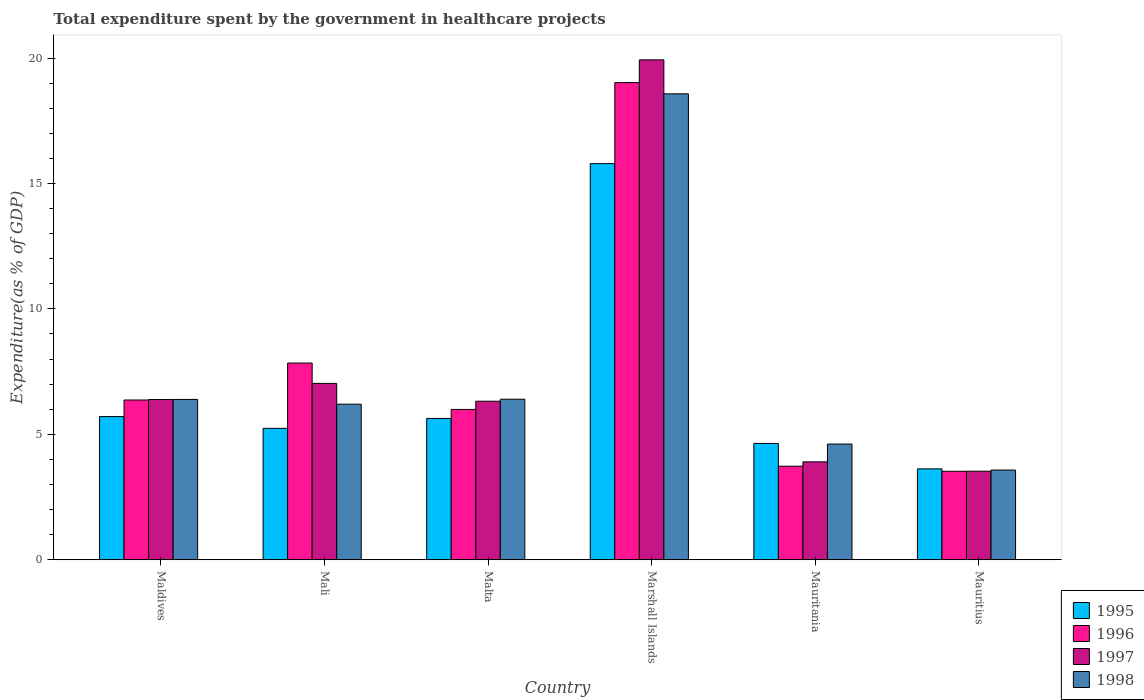Are the number of bars per tick equal to the number of legend labels?
Make the answer very short. Yes. Are the number of bars on each tick of the X-axis equal?
Offer a terse response. Yes. How many bars are there on the 6th tick from the left?
Provide a succinct answer. 4. What is the label of the 4th group of bars from the left?
Ensure brevity in your answer.  Marshall Islands. What is the total expenditure spent by the government in healthcare projects in 1997 in Mauritania?
Ensure brevity in your answer.  3.9. Across all countries, what is the maximum total expenditure spent by the government in healthcare projects in 1995?
Keep it short and to the point. 15.79. Across all countries, what is the minimum total expenditure spent by the government in healthcare projects in 1995?
Provide a succinct answer. 3.62. In which country was the total expenditure spent by the government in healthcare projects in 1995 maximum?
Provide a succinct answer. Marshall Islands. In which country was the total expenditure spent by the government in healthcare projects in 1998 minimum?
Your answer should be compact. Mauritius. What is the total total expenditure spent by the government in healthcare projects in 1996 in the graph?
Provide a succinct answer. 46.48. What is the difference between the total expenditure spent by the government in healthcare projects in 1995 in Malta and that in Marshall Islands?
Your answer should be compact. -10.16. What is the difference between the total expenditure spent by the government in healthcare projects in 1997 in Mali and the total expenditure spent by the government in healthcare projects in 1996 in Mauritius?
Make the answer very short. 3.5. What is the average total expenditure spent by the government in healthcare projects in 1997 per country?
Provide a short and direct response. 7.85. What is the difference between the total expenditure spent by the government in healthcare projects of/in 1995 and total expenditure spent by the government in healthcare projects of/in 1997 in Mauritania?
Give a very brief answer. 0.73. In how many countries, is the total expenditure spent by the government in healthcare projects in 1995 greater than 6 %?
Your answer should be compact. 1. What is the ratio of the total expenditure spent by the government in healthcare projects in 1997 in Mali to that in Marshall Islands?
Your response must be concise. 0.35. Is the total expenditure spent by the government in healthcare projects in 1998 in Maldives less than that in Mali?
Provide a succinct answer. No. What is the difference between the highest and the second highest total expenditure spent by the government in healthcare projects in 1996?
Keep it short and to the point. 12.65. What is the difference between the highest and the lowest total expenditure spent by the government in healthcare projects in 1998?
Your answer should be very brief. 15. In how many countries, is the total expenditure spent by the government in healthcare projects in 1996 greater than the average total expenditure spent by the government in healthcare projects in 1996 taken over all countries?
Offer a terse response. 2. Is it the case that in every country, the sum of the total expenditure spent by the government in healthcare projects in 1995 and total expenditure spent by the government in healthcare projects in 1996 is greater than the sum of total expenditure spent by the government in healthcare projects in 1997 and total expenditure spent by the government in healthcare projects in 1998?
Offer a very short reply. No. What does the 3rd bar from the right in Marshall Islands represents?
Offer a terse response. 1996. How many bars are there?
Provide a short and direct response. 24. What is the difference between two consecutive major ticks on the Y-axis?
Ensure brevity in your answer.  5. Are the values on the major ticks of Y-axis written in scientific E-notation?
Provide a short and direct response. No. Where does the legend appear in the graph?
Your response must be concise. Bottom right. How are the legend labels stacked?
Offer a terse response. Vertical. What is the title of the graph?
Your answer should be very brief. Total expenditure spent by the government in healthcare projects. What is the label or title of the X-axis?
Provide a succinct answer. Country. What is the label or title of the Y-axis?
Give a very brief answer. Expenditure(as % of GDP). What is the Expenditure(as % of GDP) of 1995 in Maldives?
Your answer should be very brief. 5.71. What is the Expenditure(as % of GDP) of 1996 in Maldives?
Provide a succinct answer. 6.37. What is the Expenditure(as % of GDP) of 1997 in Maldives?
Offer a very short reply. 6.39. What is the Expenditure(as % of GDP) in 1998 in Maldives?
Your response must be concise. 6.39. What is the Expenditure(as % of GDP) of 1995 in Mali?
Give a very brief answer. 5.24. What is the Expenditure(as % of GDP) of 1996 in Mali?
Your response must be concise. 7.84. What is the Expenditure(as % of GDP) of 1997 in Mali?
Your response must be concise. 7.03. What is the Expenditure(as % of GDP) in 1998 in Mali?
Make the answer very short. 6.2. What is the Expenditure(as % of GDP) in 1995 in Malta?
Make the answer very short. 5.63. What is the Expenditure(as % of GDP) of 1996 in Malta?
Keep it short and to the point. 5.99. What is the Expenditure(as % of GDP) in 1997 in Malta?
Provide a succinct answer. 6.32. What is the Expenditure(as % of GDP) in 1998 in Malta?
Ensure brevity in your answer.  6.4. What is the Expenditure(as % of GDP) of 1995 in Marshall Islands?
Your answer should be very brief. 15.79. What is the Expenditure(as % of GDP) in 1996 in Marshall Islands?
Your answer should be compact. 19.02. What is the Expenditure(as % of GDP) of 1997 in Marshall Islands?
Your response must be concise. 19.93. What is the Expenditure(as % of GDP) of 1998 in Marshall Islands?
Your answer should be very brief. 18.57. What is the Expenditure(as % of GDP) in 1995 in Mauritania?
Your answer should be very brief. 4.64. What is the Expenditure(as % of GDP) in 1996 in Mauritania?
Your answer should be very brief. 3.73. What is the Expenditure(as % of GDP) in 1997 in Mauritania?
Offer a terse response. 3.9. What is the Expenditure(as % of GDP) in 1998 in Mauritania?
Give a very brief answer. 4.61. What is the Expenditure(as % of GDP) of 1995 in Mauritius?
Offer a terse response. 3.62. What is the Expenditure(as % of GDP) of 1996 in Mauritius?
Provide a short and direct response. 3.53. What is the Expenditure(as % of GDP) of 1997 in Mauritius?
Your response must be concise. 3.53. What is the Expenditure(as % of GDP) in 1998 in Mauritius?
Your answer should be very brief. 3.58. Across all countries, what is the maximum Expenditure(as % of GDP) in 1995?
Give a very brief answer. 15.79. Across all countries, what is the maximum Expenditure(as % of GDP) of 1996?
Offer a very short reply. 19.02. Across all countries, what is the maximum Expenditure(as % of GDP) of 1997?
Provide a short and direct response. 19.93. Across all countries, what is the maximum Expenditure(as % of GDP) in 1998?
Your answer should be compact. 18.57. Across all countries, what is the minimum Expenditure(as % of GDP) in 1995?
Provide a succinct answer. 3.62. Across all countries, what is the minimum Expenditure(as % of GDP) of 1996?
Make the answer very short. 3.53. Across all countries, what is the minimum Expenditure(as % of GDP) in 1997?
Give a very brief answer. 3.53. Across all countries, what is the minimum Expenditure(as % of GDP) of 1998?
Offer a very short reply. 3.58. What is the total Expenditure(as % of GDP) of 1995 in the graph?
Ensure brevity in your answer.  40.63. What is the total Expenditure(as % of GDP) of 1996 in the graph?
Your response must be concise. 46.48. What is the total Expenditure(as % of GDP) of 1997 in the graph?
Provide a succinct answer. 47.09. What is the total Expenditure(as % of GDP) of 1998 in the graph?
Give a very brief answer. 45.75. What is the difference between the Expenditure(as % of GDP) in 1995 in Maldives and that in Mali?
Give a very brief answer. 0.47. What is the difference between the Expenditure(as % of GDP) in 1996 in Maldives and that in Mali?
Your answer should be compact. -1.47. What is the difference between the Expenditure(as % of GDP) in 1997 in Maldives and that in Mali?
Your answer should be very brief. -0.64. What is the difference between the Expenditure(as % of GDP) of 1998 in Maldives and that in Mali?
Keep it short and to the point. 0.19. What is the difference between the Expenditure(as % of GDP) of 1995 in Maldives and that in Malta?
Offer a very short reply. 0.07. What is the difference between the Expenditure(as % of GDP) of 1996 in Maldives and that in Malta?
Offer a very short reply. 0.38. What is the difference between the Expenditure(as % of GDP) in 1997 in Maldives and that in Malta?
Your answer should be very brief. 0.07. What is the difference between the Expenditure(as % of GDP) of 1998 in Maldives and that in Malta?
Ensure brevity in your answer.  -0.01. What is the difference between the Expenditure(as % of GDP) in 1995 in Maldives and that in Marshall Islands?
Offer a terse response. -10.08. What is the difference between the Expenditure(as % of GDP) of 1996 in Maldives and that in Marshall Islands?
Your answer should be very brief. -12.65. What is the difference between the Expenditure(as % of GDP) of 1997 in Maldives and that in Marshall Islands?
Keep it short and to the point. -13.54. What is the difference between the Expenditure(as % of GDP) of 1998 in Maldives and that in Marshall Islands?
Your response must be concise. -12.18. What is the difference between the Expenditure(as % of GDP) of 1995 in Maldives and that in Mauritania?
Make the answer very short. 1.07. What is the difference between the Expenditure(as % of GDP) of 1996 in Maldives and that in Mauritania?
Ensure brevity in your answer.  2.64. What is the difference between the Expenditure(as % of GDP) in 1997 in Maldives and that in Mauritania?
Give a very brief answer. 2.48. What is the difference between the Expenditure(as % of GDP) of 1998 in Maldives and that in Mauritania?
Offer a very short reply. 1.78. What is the difference between the Expenditure(as % of GDP) in 1995 in Maldives and that in Mauritius?
Make the answer very short. 2.08. What is the difference between the Expenditure(as % of GDP) in 1996 in Maldives and that in Mauritius?
Your response must be concise. 2.84. What is the difference between the Expenditure(as % of GDP) of 1997 in Maldives and that in Mauritius?
Offer a terse response. 2.86. What is the difference between the Expenditure(as % of GDP) of 1998 in Maldives and that in Mauritius?
Provide a succinct answer. 2.82. What is the difference between the Expenditure(as % of GDP) in 1995 in Mali and that in Malta?
Offer a terse response. -0.4. What is the difference between the Expenditure(as % of GDP) in 1996 in Mali and that in Malta?
Provide a succinct answer. 1.85. What is the difference between the Expenditure(as % of GDP) of 1997 in Mali and that in Malta?
Make the answer very short. 0.71. What is the difference between the Expenditure(as % of GDP) in 1998 in Mali and that in Malta?
Ensure brevity in your answer.  -0.2. What is the difference between the Expenditure(as % of GDP) in 1995 in Mali and that in Marshall Islands?
Offer a terse response. -10.55. What is the difference between the Expenditure(as % of GDP) in 1996 in Mali and that in Marshall Islands?
Your answer should be very brief. -11.18. What is the difference between the Expenditure(as % of GDP) of 1997 in Mali and that in Marshall Islands?
Provide a short and direct response. -12.9. What is the difference between the Expenditure(as % of GDP) of 1998 in Mali and that in Marshall Islands?
Offer a very short reply. -12.37. What is the difference between the Expenditure(as % of GDP) of 1995 in Mali and that in Mauritania?
Keep it short and to the point. 0.6. What is the difference between the Expenditure(as % of GDP) in 1996 in Mali and that in Mauritania?
Offer a very short reply. 4.11. What is the difference between the Expenditure(as % of GDP) of 1997 in Mali and that in Mauritania?
Your response must be concise. 3.13. What is the difference between the Expenditure(as % of GDP) of 1998 in Mali and that in Mauritania?
Offer a terse response. 1.59. What is the difference between the Expenditure(as % of GDP) in 1995 in Mali and that in Mauritius?
Your answer should be very brief. 1.61. What is the difference between the Expenditure(as % of GDP) of 1996 in Mali and that in Mauritius?
Provide a succinct answer. 4.31. What is the difference between the Expenditure(as % of GDP) in 1997 in Mali and that in Mauritius?
Provide a succinct answer. 3.5. What is the difference between the Expenditure(as % of GDP) of 1998 in Mali and that in Mauritius?
Provide a succinct answer. 2.63. What is the difference between the Expenditure(as % of GDP) in 1995 in Malta and that in Marshall Islands?
Offer a terse response. -10.16. What is the difference between the Expenditure(as % of GDP) of 1996 in Malta and that in Marshall Islands?
Make the answer very short. -13.03. What is the difference between the Expenditure(as % of GDP) of 1997 in Malta and that in Marshall Islands?
Offer a terse response. -13.61. What is the difference between the Expenditure(as % of GDP) of 1998 in Malta and that in Marshall Islands?
Your response must be concise. -12.17. What is the difference between the Expenditure(as % of GDP) of 1996 in Malta and that in Mauritania?
Give a very brief answer. 2.26. What is the difference between the Expenditure(as % of GDP) of 1997 in Malta and that in Mauritania?
Your answer should be very brief. 2.42. What is the difference between the Expenditure(as % of GDP) of 1998 in Malta and that in Mauritania?
Provide a succinct answer. 1.79. What is the difference between the Expenditure(as % of GDP) of 1995 in Malta and that in Mauritius?
Your answer should be very brief. 2.01. What is the difference between the Expenditure(as % of GDP) of 1996 in Malta and that in Mauritius?
Make the answer very short. 2.46. What is the difference between the Expenditure(as % of GDP) of 1997 in Malta and that in Mauritius?
Keep it short and to the point. 2.79. What is the difference between the Expenditure(as % of GDP) of 1998 in Malta and that in Mauritius?
Your response must be concise. 2.82. What is the difference between the Expenditure(as % of GDP) in 1995 in Marshall Islands and that in Mauritania?
Give a very brief answer. 11.15. What is the difference between the Expenditure(as % of GDP) in 1996 in Marshall Islands and that in Mauritania?
Provide a short and direct response. 15.29. What is the difference between the Expenditure(as % of GDP) in 1997 in Marshall Islands and that in Mauritania?
Your answer should be very brief. 16.02. What is the difference between the Expenditure(as % of GDP) in 1998 in Marshall Islands and that in Mauritania?
Your answer should be compact. 13.96. What is the difference between the Expenditure(as % of GDP) in 1995 in Marshall Islands and that in Mauritius?
Make the answer very short. 12.17. What is the difference between the Expenditure(as % of GDP) in 1996 in Marshall Islands and that in Mauritius?
Your answer should be very brief. 15.49. What is the difference between the Expenditure(as % of GDP) of 1997 in Marshall Islands and that in Mauritius?
Your answer should be very brief. 16.4. What is the difference between the Expenditure(as % of GDP) in 1998 in Marshall Islands and that in Mauritius?
Offer a very short reply. 15. What is the difference between the Expenditure(as % of GDP) of 1995 in Mauritania and that in Mauritius?
Provide a short and direct response. 1.01. What is the difference between the Expenditure(as % of GDP) of 1996 in Mauritania and that in Mauritius?
Provide a short and direct response. 0.2. What is the difference between the Expenditure(as % of GDP) in 1997 in Mauritania and that in Mauritius?
Your answer should be very brief. 0.37. What is the difference between the Expenditure(as % of GDP) of 1998 in Mauritania and that in Mauritius?
Your answer should be very brief. 1.04. What is the difference between the Expenditure(as % of GDP) in 1995 in Maldives and the Expenditure(as % of GDP) in 1996 in Mali?
Your answer should be very brief. -2.13. What is the difference between the Expenditure(as % of GDP) of 1995 in Maldives and the Expenditure(as % of GDP) of 1997 in Mali?
Your answer should be very brief. -1.32. What is the difference between the Expenditure(as % of GDP) of 1995 in Maldives and the Expenditure(as % of GDP) of 1998 in Mali?
Your answer should be very brief. -0.49. What is the difference between the Expenditure(as % of GDP) in 1996 in Maldives and the Expenditure(as % of GDP) in 1997 in Mali?
Offer a terse response. -0.66. What is the difference between the Expenditure(as % of GDP) in 1996 in Maldives and the Expenditure(as % of GDP) in 1998 in Mali?
Your answer should be compact. 0.17. What is the difference between the Expenditure(as % of GDP) in 1997 in Maldives and the Expenditure(as % of GDP) in 1998 in Mali?
Your response must be concise. 0.19. What is the difference between the Expenditure(as % of GDP) of 1995 in Maldives and the Expenditure(as % of GDP) of 1996 in Malta?
Make the answer very short. -0.28. What is the difference between the Expenditure(as % of GDP) in 1995 in Maldives and the Expenditure(as % of GDP) in 1997 in Malta?
Offer a terse response. -0.61. What is the difference between the Expenditure(as % of GDP) of 1995 in Maldives and the Expenditure(as % of GDP) of 1998 in Malta?
Ensure brevity in your answer.  -0.69. What is the difference between the Expenditure(as % of GDP) of 1996 in Maldives and the Expenditure(as % of GDP) of 1997 in Malta?
Ensure brevity in your answer.  0.05. What is the difference between the Expenditure(as % of GDP) in 1996 in Maldives and the Expenditure(as % of GDP) in 1998 in Malta?
Keep it short and to the point. -0.03. What is the difference between the Expenditure(as % of GDP) in 1997 in Maldives and the Expenditure(as % of GDP) in 1998 in Malta?
Your response must be concise. -0.01. What is the difference between the Expenditure(as % of GDP) in 1995 in Maldives and the Expenditure(as % of GDP) in 1996 in Marshall Islands?
Your answer should be very brief. -13.31. What is the difference between the Expenditure(as % of GDP) in 1995 in Maldives and the Expenditure(as % of GDP) in 1997 in Marshall Islands?
Give a very brief answer. -14.22. What is the difference between the Expenditure(as % of GDP) of 1995 in Maldives and the Expenditure(as % of GDP) of 1998 in Marshall Islands?
Offer a very short reply. -12.86. What is the difference between the Expenditure(as % of GDP) in 1996 in Maldives and the Expenditure(as % of GDP) in 1997 in Marshall Islands?
Your response must be concise. -13.56. What is the difference between the Expenditure(as % of GDP) of 1996 in Maldives and the Expenditure(as % of GDP) of 1998 in Marshall Islands?
Offer a terse response. -12.2. What is the difference between the Expenditure(as % of GDP) in 1997 in Maldives and the Expenditure(as % of GDP) in 1998 in Marshall Islands?
Keep it short and to the point. -12.19. What is the difference between the Expenditure(as % of GDP) of 1995 in Maldives and the Expenditure(as % of GDP) of 1996 in Mauritania?
Your answer should be very brief. 1.98. What is the difference between the Expenditure(as % of GDP) in 1995 in Maldives and the Expenditure(as % of GDP) in 1997 in Mauritania?
Give a very brief answer. 1.81. What is the difference between the Expenditure(as % of GDP) in 1995 in Maldives and the Expenditure(as % of GDP) in 1998 in Mauritania?
Offer a terse response. 1.1. What is the difference between the Expenditure(as % of GDP) in 1996 in Maldives and the Expenditure(as % of GDP) in 1997 in Mauritania?
Give a very brief answer. 2.46. What is the difference between the Expenditure(as % of GDP) in 1996 in Maldives and the Expenditure(as % of GDP) in 1998 in Mauritania?
Your response must be concise. 1.76. What is the difference between the Expenditure(as % of GDP) of 1997 in Maldives and the Expenditure(as % of GDP) of 1998 in Mauritania?
Your response must be concise. 1.78. What is the difference between the Expenditure(as % of GDP) of 1995 in Maldives and the Expenditure(as % of GDP) of 1996 in Mauritius?
Ensure brevity in your answer.  2.18. What is the difference between the Expenditure(as % of GDP) of 1995 in Maldives and the Expenditure(as % of GDP) of 1997 in Mauritius?
Ensure brevity in your answer.  2.18. What is the difference between the Expenditure(as % of GDP) in 1995 in Maldives and the Expenditure(as % of GDP) in 1998 in Mauritius?
Offer a terse response. 2.13. What is the difference between the Expenditure(as % of GDP) of 1996 in Maldives and the Expenditure(as % of GDP) of 1997 in Mauritius?
Ensure brevity in your answer.  2.84. What is the difference between the Expenditure(as % of GDP) of 1996 in Maldives and the Expenditure(as % of GDP) of 1998 in Mauritius?
Ensure brevity in your answer.  2.79. What is the difference between the Expenditure(as % of GDP) in 1997 in Maldives and the Expenditure(as % of GDP) in 1998 in Mauritius?
Your answer should be very brief. 2.81. What is the difference between the Expenditure(as % of GDP) of 1995 in Mali and the Expenditure(as % of GDP) of 1996 in Malta?
Provide a succinct answer. -0.75. What is the difference between the Expenditure(as % of GDP) of 1995 in Mali and the Expenditure(as % of GDP) of 1997 in Malta?
Offer a terse response. -1.08. What is the difference between the Expenditure(as % of GDP) in 1995 in Mali and the Expenditure(as % of GDP) in 1998 in Malta?
Keep it short and to the point. -1.16. What is the difference between the Expenditure(as % of GDP) of 1996 in Mali and the Expenditure(as % of GDP) of 1997 in Malta?
Keep it short and to the point. 1.52. What is the difference between the Expenditure(as % of GDP) of 1996 in Mali and the Expenditure(as % of GDP) of 1998 in Malta?
Make the answer very short. 1.44. What is the difference between the Expenditure(as % of GDP) of 1997 in Mali and the Expenditure(as % of GDP) of 1998 in Malta?
Ensure brevity in your answer.  0.63. What is the difference between the Expenditure(as % of GDP) in 1995 in Mali and the Expenditure(as % of GDP) in 1996 in Marshall Islands?
Offer a very short reply. -13.78. What is the difference between the Expenditure(as % of GDP) in 1995 in Mali and the Expenditure(as % of GDP) in 1997 in Marshall Islands?
Your answer should be very brief. -14.69. What is the difference between the Expenditure(as % of GDP) in 1995 in Mali and the Expenditure(as % of GDP) in 1998 in Marshall Islands?
Give a very brief answer. -13.33. What is the difference between the Expenditure(as % of GDP) of 1996 in Mali and the Expenditure(as % of GDP) of 1997 in Marshall Islands?
Provide a succinct answer. -12.08. What is the difference between the Expenditure(as % of GDP) of 1996 in Mali and the Expenditure(as % of GDP) of 1998 in Marshall Islands?
Make the answer very short. -10.73. What is the difference between the Expenditure(as % of GDP) in 1997 in Mali and the Expenditure(as % of GDP) in 1998 in Marshall Islands?
Your response must be concise. -11.54. What is the difference between the Expenditure(as % of GDP) of 1995 in Mali and the Expenditure(as % of GDP) of 1996 in Mauritania?
Offer a very short reply. 1.51. What is the difference between the Expenditure(as % of GDP) in 1995 in Mali and the Expenditure(as % of GDP) in 1997 in Mauritania?
Your response must be concise. 1.34. What is the difference between the Expenditure(as % of GDP) of 1995 in Mali and the Expenditure(as % of GDP) of 1998 in Mauritania?
Offer a terse response. 0.63. What is the difference between the Expenditure(as % of GDP) in 1996 in Mali and the Expenditure(as % of GDP) in 1997 in Mauritania?
Provide a succinct answer. 3.94. What is the difference between the Expenditure(as % of GDP) of 1996 in Mali and the Expenditure(as % of GDP) of 1998 in Mauritania?
Ensure brevity in your answer.  3.23. What is the difference between the Expenditure(as % of GDP) in 1997 in Mali and the Expenditure(as % of GDP) in 1998 in Mauritania?
Provide a succinct answer. 2.42. What is the difference between the Expenditure(as % of GDP) of 1995 in Mali and the Expenditure(as % of GDP) of 1996 in Mauritius?
Offer a terse response. 1.71. What is the difference between the Expenditure(as % of GDP) in 1995 in Mali and the Expenditure(as % of GDP) in 1997 in Mauritius?
Ensure brevity in your answer.  1.71. What is the difference between the Expenditure(as % of GDP) of 1995 in Mali and the Expenditure(as % of GDP) of 1998 in Mauritius?
Your answer should be very brief. 1.66. What is the difference between the Expenditure(as % of GDP) of 1996 in Mali and the Expenditure(as % of GDP) of 1997 in Mauritius?
Give a very brief answer. 4.31. What is the difference between the Expenditure(as % of GDP) in 1996 in Mali and the Expenditure(as % of GDP) in 1998 in Mauritius?
Make the answer very short. 4.27. What is the difference between the Expenditure(as % of GDP) in 1997 in Mali and the Expenditure(as % of GDP) in 1998 in Mauritius?
Offer a very short reply. 3.45. What is the difference between the Expenditure(as % of GDP) in 1995 in Malta and the Expenditure(as % of GDP) in 1996 in Marshall Islands?
Your answer should be very brief. -13.39. What is the difference between the Expenditure(as % of GDP) of 1995 in Malta and the Expenditure(as % of GDP) of 1997 in Marshall Islands?
Your response must be concise. -14.29. What is the difference between the Expenditure(as % of GDP) in 1995 in Malta and the Expenditure(as % of GDP) in 1998 in Marshall Islands?
Your response must be concise. -12.94. What is the difference between the Expenditure(as % of GDP) in 1996 in Malta and the Expenditure(as % of GDP) in 1997 in Marshall Islands?
Ensure brevity in your answer.  -13.93. What is the difference between the Expenditure(as % of GDP) in 1996 in Malta and the Expenditure(as % of GDP) in 1998 in Marshall Islands?
Make the answer very short. -12.58. What is the difference between the Expenditure(as % of GDP) in 1997 in Malta and the Expenditure(as % of GDP) in 1998 in Marshall Islands?
Your response must be concise. -12.25. What is the difference between the Expenditure(as % of GDP) in 1995 in Malta and the Expenditure(as % of GDP) in 1996 in Mauritania?
Offer a terse response. 1.9. What is the difference between the Expenditure(as % of GDP) in 1995 in Malta and the Expenditure(as % of GDP) in 1997 in Mauritania?
Provide a succinct answer. 1.73. What is the difference between the Expenditure(as % of GDP) of 1995 in Malta and the Expenditure(as % of GDP) of 1998 in Mauritania?
Make the answer very short. 1.02. What is the difference between the Expenditure(as % of GDP) in 1996 in Malta and the Expenditure(as % of GDP) in 1997 in Mauritania?
Your answer should be compact. 2.09. What is the difference between the Expenditure(as % of GDP) of 1996 in Malta and the Expenditure(as % of GDP) of 1998 in Mauritania?
Give a very brief answer. 1.38. What is the difference between the Expenditure(as % of GDP) of 1997 in Malta and the Expenditure(as % of GDP) of 1998 in Mauritania?
Keep it short and to the point. 1.71. What is the difference between the Expenditure(as % of GDP) in 1995 in Malta and the Expenditure(as % of GDP) in 1996 in Mauritius?
Give a very brief answer. 2.11. What is the difference between the Expenditure(as % of GDP) of 1995 in Malta and the Expenditure(as % of GDP) of 1997 in Mauritius?
Your answer should be compact. 2.1. What is the difference between the Expenditure(as % of GDP) in 1995 in Malta and the Expenditure(as % of GDP) in 1998 in Mauritius?
Provide a short and direct response. 2.06. What is the difference between the Expenditure(as % of GDP) of 1996 in Malta and the Expenditure(as % of GDP) of 1997 in Mauritius?
Give a very brief answer. 2.46. What is the difference between the Expenditure(as % of GDP) in 1996 in Malta and the Expenditure(as % of GDP) in 1998 in Mauritius?
Provide a short and direct response. 2.42. What is the difference between the Expenditure(as % of GDP) of 1997 in Malta and the Expenditure(as % of GDP) of 1998 in Mauritius?
Provide a short and direct response. 2.74. What is the difference between the Expenditure(as % of GDP) in 1995 in Marshall Islands and the Expenditure(as % of GDP) in 1996 in Mauritania?
Give a very brief answer. 12.06. What is the difference between the Expenditure(as % of GDP) in 1995 in Marshall Islands and the Expenditure(as % of GDP) in 1997 in Mauritania?
Make the answer very short. 11.89. What is the difference between the Expenditure(as % of GDP) in 1995 in Marshall Islands and the Expenditure(as % of GDP) in 1998 in Mauritania?
Give a very brief answer. 11.18. What is the difference between the Expenditure(as % of GDP) in 1996 in Marshall Islands and the Expenditure(as % of GDP) in 1997 in Mauritania?
Your answer should be very brief. 15.12. What is the difference between the Expenditure(as % of GDP) of 1996 in Marshall Islands and the Expenditure(as % of GDP) of 1998 in Mauritania?
Offer a very short reply. 14.41. What is the difference between the Expenditure(as % of GDP) of 1997 in Marshall Islands and the Expenditure(as % of GDP) of 1998 in Mauritania?
Offer a terse response. 15.31. What is the difference between the Expenditure(as % of GDP) in 1995 in Marshall Islands and the Expenditure(as % of GDP) in 1996 in Mauritius?
Your answer should be compact. 12.26. What is the difference between the Expenditure(as % of GDP) in 1995 in Marshall Islands and the Expenditure(as % of GDP) in 1997 in Mauritius?
Your answer should be compact. 12.26. What is the difference between the Expenditure(as % of GDP) in 1995 in Marshall Islands and the Expenditure(as % of GDP) in 1998 in Mauritius?
Keep it short and to the point. 12.21. What is the difference between the Expenditure(as % of GDP) of 1996 in Marshall Islands and the Expenditure(as % of GDP) of 1997 in Mauritius?
Provide a succinct answer. 15.49. What is the difference between the Expenditure(as % of GDP) in 1996 in Marshall Islands and the Expenditure(as % of GDP) in 1998 in Mauritius?
Offer a terse response. 15.44. What is the difference between the Expenditure(as % of GDP) of 1997 in Marshall Islands and the Expenditure(as % of GDP) of 1998 in Mauritius?
Provide a short and direct response. 16.35. What is the difference between the Expenditure(as % of GDP) of 1995 in Mauritania and the Expenditure(as % of GDP) of 1996 in Mauritius?
Keep it short and to the point. 1.11. What is the difference between the Expenditure(as % of GDP) in 1995 in Mauritania and the Expenditure(as % of GDP) in 1997 in Mauritius?
Give a very brief answer. 1.11. What is the difference between the Expenditure(as % of GDP) in 1995 in Mauritania and the Expenditure(as % of GDP) in 1998 in Mauritius?
Your response must be concise. 1.06. What is the difference between the Expenditure(as % of GDP) in 1996 in Mauritania and the Expenditure(as % of GDP) in 1997 in Mauritius?
Keep it short and to the point. 0.2. What is the difference between the Expenditure(as % of GDP) of 1996 in Mauritania and the Expenditure(as % of GDP) of 1998 in Mauritius?
Offer a terse response. 0.15. What is the difference between the Expenditure(as % of GDP) in 1997 in Mauritania and the Expenditure(as % of GDP) in 1998 in Mauritius?
Keep it short and to the point. 0.33. What is the average Expenditure(as % of GDP) in 1995 per country?
Your answer should be very brief. 6.77. What is the average Expenditure(as % of GDP) in 1996 per country?
Offer a terse response. 7.75. What is the average Expenditure(as % of GDP) of 1997 per country?
Your response must be concise. 7.85. What is the average Expenditure(as % of GDP) in 1998 per country?
Ensure brevity in your answer.  7.63. What is the difference between the Expenditure(as % of GDP) in 1995 and Expenditure(as % of GDP) in 1996 in Maldives?
Your response must be concise. -0.66. What is the difference between the Expenditure(as % of GDP) in 1995 and Expenditure(as % of GDP) in 1997 in Maldives?
Give a very brief answer. -0.68. What is the difference between the Expenditure(as % of GDP) in 1995 and Expenditure(as % of GDP) in 1998 in Maldives?
Make the answer very short. -0.68. What is the difference between the Expenditure(as % of GDP) of 1996 and Expenditure(as % of GDP) of 1997 in Maldives?
Give a very brief answer. -0.02. What is the difference between the Expenditure(as % of GDP) in 1996 and Expenditure(as % of GDP) in 1998 in Maldives?
Give a very brief answer. -0.02. What is the difference between the Expenditure(as % of GDP) in 1997 and Expenditure(as % of GDP) in 1998 in Maldives?
Make the answer very short. -0. What is the difference between the Expenditure(as % of GDP) in 1995 and Expenditure(as % of GDP) in 1996 in Mali?
Keep it short and to the point. -2.6. What is the difference between the Expenditure(as % of GDP) in 1995 and Expenditure(as % of GDP) in 1997 in Mali?
Provide a succinct answer. -1.79. What is the difference between the Expenditure(as % of GDP) in 1995 and Expenditure(as % of GDP) in 1998 in Mali?
Your answer should be compact. -0.96. What is the difference between the Expenditure(as % of GDP) in 1996 and Expenditure(as % of GDP) in 1997 in Mali?
Provide a succinct answer. 0.81. What is the difference between the Expenditure(as % of GDP) of 1996 and Expenditure(as % of GDP) of 1998 in Mali?
Ensure brevity in your answer.  1.64. What is the difference between the Expenditure(as % of GDP) in 1997 and Expenditure(as % of GDP) in 1998 in Mali?
Your answer should be very brief. 0.83. What is the difference between the Expenditure(as % of GDP) in 1995 and Expenditure(as % of GDP) in 1996 in Malta?
Offer a terse response. -0.36. What is the difference between the Expenditure(as % of GDP) in 1995 and Expenditure(as % of GDP) in 1997 in Malta?
Offer a terse response. -0.69. What is the difference between the Expenditure(as % of GDP) in 1995 and Expenditure(as % of GDP) in 1998 in Malta?
Provide a succinct answer. -0.77. What is the difference between the Expenditure(as % of GDP) in 1996 and Expenditure(as % of GDP) in 1997 in Malta?
Provide a succinct answer. -0.33. What is the difference between the Expenditure(as % of GDP) of 1996 and Expenditure(as % of GDP) of 1998 in Malta?
Offer a very short reply. -0.41. What is the difference between the Expenditure(as % of GDP) in 1997 and Expenditure(as % of GDP) in 1998 in Malta?
Your answer should be compact. -0.08. What is the difference between the Expenditure(as % of GDP) in 1995 and Expenditure(as % of GDP) in 1996 in Marshall Islands?
Offer a terse response. -3.23. What is the difference between the Expenditure(as % of GDP) in 1995 and Expenditure(as % of GDP) in 1997 in Marshall Islands?
Keep it short and to the point. -4.14. What is the difference between the Expenditure(as % of GDP) in 1995 and Expenditure(as % of GDP) in 1998 in Marshall Islands?
Make the answer very short. -2.78. What is the difference between the Expenditure(as % of GDP) in 1996 and Expenditure(as % of GDP) in 1997 in Marshall Islands?
Offer a terse response. -0.91. What is the difference between the Expenditure(as % of GDP) in 1996 and Expenditure(as % of GDP) in 1998 in Marshall Islands?
Provide a short and direct response. 0.45. What is the difference between the Expenditure(as % of GDP) of 1997 and Expenditure(as % of GDP) of 1998 in Marshall Islands?
Your answer should be very brief. 1.35. What is the difference between the Expenditure(as % of GDP) in 1995 and Expenditure(as % of GDP) in 1996 in Mauritania?
Offer a terse response. 0.91. What is the difference between the Expenditure(as % of GDP) of 1995 and Expenditure(as % of GDP) of 1997 in Mauritania?
Ensure brevity in your answer.  0.73. What is the difference between the Expenditure(as % of GDP) of 1995 and Expenditure(as % of GDP) of 1998 in Mauritania?
Your answer should be very brief. 0.03. What is the difference between the Expenditure(as % of GDP) of 1996 and Expenditure(as % of GDP) of 1997 in Mauritania?
Your answer should be compact. -0.17. What is the difference between the Expenditure(as % of GDP) in 1996 and Expenditure(as % of GDP) in 1998 in Mauritania?
Keep it short and to the point. -0.88. What is the difference between the Expenditure(as % of GDP) of 1997 and Expenditure(as % of GDP) of 1998 in Mauritania?
Offer a very short reply. -0.71. What is the difference between the Expenditure(as % of GDP) in 1995 and Expenditure(as % of GDP) in 1996 in Mauritius?
Your response must be concise. 0.1. What is the difference between the Expenditure(as % of GDP) in 1995 and Expenditure(as % of GDP) in 1997 in Mauritius?
Offer a terse response. 0.09. What is the difference between the Expenditure(as % of GDP) in 1995 and Expenditure(as % of GDP) in 1998 in Mauritius?
Ensure brevity in your answer.  0.05. What is the difference between the Expenditure(as % of GDP) of 1996 and Expenditure(as % of GDP) of 1997 in Mauritius?
Ensure brevity in your answer.  -0. What is the difference between the Expenditure(as % of GDP) in 1996 and Expenditure(as % of GDP) in 1998 in Mauritius?
Offer a very short reply. -0.05. What is the difference between the Expenditure(as % of GDP) of 1997 and Expenditure(as % of GDP) of 1998 in Mauritius?
Your response must be concise. -0.05. What is the ratio of the Expenditure(as % of GDP) of 1995 in Maldives to that in Mali?
Your answer should be compact. 1.09. What is the ratio of the Expenditure(as % of GDP) of 1996 in Maldives to that in Mali?
Your answer should be compact. 0.81. What is the ratio of the Expenditure(as % of GDP) of 1997 in Maldives to that in Mali?
Provide a short and direct response. 0.91. What is the ratio of the Expenditure(as % of GDP) in 1998 in Maldives to that in Mali?
Provide a succinct answer. 1.03. What is the ratio of the Expenditure(as % of GDP) of 1995 in Maldives to that in Malta?
Offer a terse response. 1.01. What is the ratio of the Expenditure(as % of GDP) of 1996 in Maldives to that in Malta?
Keep it short and to the point. 1.06. What is the ratio of the Expenditure(as % of GDP) in 1997 in Maldives to that in Malta?
Provide a short and direct response. 1.01. What is the ratio of the Expenditure(as % of GDP) in 1998 in Maldives to that in Malta?
Keep it short and to the point. 1. What is the ratio of the Expenditure(as % of GDP) of 1995 in Maldives to that in Marshall Islands?
Offer a terse response. 0.36. What is the ratio of the Expenditure(as % of GDP) of 1996 in Maldives to that in Marshall Islands?
Your response must be concise. 0.33. What is the ratio of the Expenditure(as % of GDP) in 1997 in Maldives to that in Marshall Islands?
Make the answer very short. 0.32. What is the ratio of the Expenditure(as % of GDP) of 1998 in Maldives to that in Marshall Islands?
Make the answer very short. 0.34. What is the ratio of the Expenditure(as % of GDP) of 1995 in Maldives to that in Mauritania?
Keep it short and to the point. 1.23. What is the ratio of the Expenditure(as % of GDP) in 1996 in Maldives to that in Mauritania?
Give a very brief answer. 1.71. What is the ratio of the Expenditure(as % of GDP) in 1997 in Maldives to that in Mauritania?
Your response must be concise. 1.64. What is the ratio of the Expenditure(as % of GDP) of 1998 in Maldives to that in Mauritania?
Ensure brevity in your answer.  1.39. What is the ratio of the Expenditure(as % of GDP) in 1995 in Maldives to that in Mauritius?
Provide a succinct answer. 1.58. What is the ratio of the Expenditure(as % of GDP) in 1996 in Maldives to that in Mauritius?
Keep it short and to the point. 1.8. What is the ratio of the Expenditure(as % of GDP) of 1997 in Maldives to that in Mauritius?
Your answer should be very brief. 1.81. What is the ratio of the Expenditure(as % of GDP) of 1998 in Maldives to that in Mauritius?
Make the answer very short. 1.79. What is the ratio of the Expenditure(as % of GDP) of 1995 in Mali to that in Malta?
Make the answer very short. 0.93. What is the ratio of the Expenditure(as % of GDP) in 1996 in Mali to that in Malta?
Provide a short and direct response. 1.31. What is the ratio of the Expenditure(as % of GDP) in 1997 in Mali to that in Malta?
Offer a very short reply. 1.11. What is the ratio of the Expenditure(as % of GDP) of 1998 in Mali to that in Malta?
Ensure brevity in your answer.  0.97. What is the ratio of the Expenditure(as % of GDP) of 1995 in Mali to that in Marshall Islands?
Ensure brevity in your answer.  0.33. What is the ratio of the Expenditure(as % of GDP) in 1996 in Mali to that in Marshall Islands?
Ensure brevity in your answer.  0.41. What is the ratio of the Expenditure(as % of GDP) of 1997 in Mali to that in Marshall Islands?
Ensure brevity in your answer.  0.35. What is the ratio of the Expenditure(as % of GDP) of 1998 in Mali to that in Marshall Islands?
Your answer should be very brief. 0.33. What is the ratio of the Expenditure(as % of GDP) in 1995 in Mali to that in Mauritania?
Provide a succinct answer. 1.13. What is the ratio of the Expenditure(as % of GDP) of 1996 in Mali to that in Mauritania?
Offer a very short reply. 2.1. What is the ratio of the Expenditure(as % of GDP) of 1997 in Mali to that in Mauritania?
Your response must be concise. 1.8. What is the ratio of the Expenditure(as % of GDP) of 1998 in Mali to that in Mauritania?
Your response must be concise. 1.34. What is the ratio of the Expenditure(as % of GDP) of 1995 in Mali to that in Mauritius?
Your answer should be very brief. 1.45. What is the ratio of the Expenditure(as % of GDP) of 1996 in Mali to that in Mauritius?
Keep it short and to the point. 2.22. What is the ratio of the Expenditure(as % of GDP) of 1997 in Mali to that in Mauritius?
Your response must be concise. 1.99. What is the ratio of the Expenditure(as % of GDP) of 1998 in Mali to that in Mauritius?
Provide a succinct answer. 1.73. What is the ratio of the Expenditure(as % of GDP) of 1995 in Malta to that in Marshall Islands?
Your answer should be compact. 0.36. What is the ratio of the Expenditure(as % of GDP) in 1996 in Malta to that in Marshall Islands?
Your response must be concise. 0.32. What is the ratio of the Expenditure(as % of GDP) of 1997 in Malta to that in Marshall Islands?
Keep it short and to the point. 0.32. What is the ratio of the Expenditure(as % of GDP) in 1998 in Malta to that in Marshall Islands?
Provide a short and direct response. 0.34. What is the ratio of the Expenditure(as % of GDP) of 1995 in Malta to that in Mauritania?
Give a very brief answer. 1.21. What is the ratio of the Expenditure(as % of GDP) of 1996 in Malta to that in Mauritania?
Provide a short and direct response. 1.61. What is the ratio of the Expenditure(as % of GDP) in 1997 in Malta to that in Mauritania?
Your answer should be compact. 1.62. What is the ratio of the Expenditure(as % of GDP) in 1998 in Malta to that in Mauritania?
Provide a short and direct response. 1.39. What is the ratio of the Expenditure(as % of GDP) in 1995 in Malta to that in Mauritius?
Provide a short and direct response. 1.55. What is the ratio of the Expenditure(as % of GDP) of 1996 in Malta to that in Mauritius?
Give a very brief answer. 1.7. What is the ratio of the Expenditure(as % of GDP) of 1997 in Malta to that in Mauritius?
Keep it short and to the point. 1.79. What is the ratio of the Expenditure(as % of GDP) in 1998 in Malta to that in Mauritius?
Your answer should be compact. 1.79. What is the ratio of the Expenditure(as % of GDP) in 1995 in Marshall Islands to that in Mauritania?
Ensure brevity in your answer.  3.41. What is the ratio of the Expenditure(as % of GDP) in 1996 in Marshall Islands to that in Mauritania?
Your answer should be compact. 5.1. What is the ratio of the Expenditure(as % of GDP) in 1997 in Marshall Islands to that in Mauritania?
Your answer should be very brief. 5.11. What is the ratio of the Expenditure(as % of GDP) in 1998 in Marshall Islands to that in Mauritania?
Your answer should be very brief. 4.03. What is the ratio of the Expenditure(as % of GDP) of 1995 in Marshall Islands to that in Mauritius?
Provide a succinct answer. 4.36. What is the ratio of the Expenditure(as % of GDP) in 1996 in Marshall Islands to that in Mauritius?
Give a very brief answer. 5.39. What is the ratio of the Expenditure(as % of GDP) in 1997 in Marshall Islands to that in Mauritius?
Provide a succinct answer. 5.65. What is the ratio of the Expenditure(as % of GDP) in 1998 in Marshall Islands to that in Mauritius?
Provide a succinct answer. 5.19. What is the ratio of the Expenditure(as % of GDP) in 1995 in Mauritania to that in Mauritius?
Give a very brief answer. 1.28. What is the ratio of the Expenditure(as % of GDP) in 1996 in Mauritania to that in Mauritius?
Your response must be concise. 1.06. What is the ratio of the Expenditure(as % of GDP) of 1997 in Mauritania to that in Mauritius?
Ensure brevity in your answer.  1.11. What is the ratio of the Expenditure(as % of GDP) of 1998 in Mauritania to that in Mauritius?
Keep it short and to the point. 1.29. What is the difference between the highest and the second highest Expenditure(as % of GDP) in 1995?
Make the answer very short. 10.08. What is the difference between the highest and the second highest Expenditure(as % of GDP) of 1996?
Ensure brevity in your answer.  11.18. What is the difference between the highest and the second highest Expenditure(as % of GDP) in 1997?
Give a very brief answer. 12.9. What is the difference between the highest and the second highest Expenditure(as % of GDP) in 1998?
Provide a short and direct response. 12.17. What is the difference between the highest and the lowest Expenditure(as % of GDP) in 1995?
Provide a short and direct response. 12.17. What is the difference between the highest and the lowest Expenditure(as % of GDP) of 1996?
Your answer should be compact. 15.49. What is the difference between the highest and the lowest Expenditure(as % of GDP) in 1997?
Your answer should be compact. 16.4. What is the difference between the highest and the lowest Expenditure(as % of GDP) in 1998?
Your answer should be very brief. 15. 